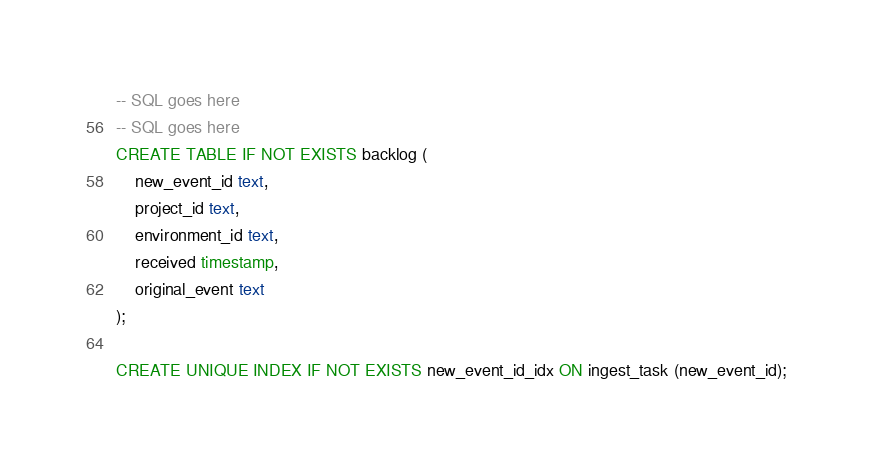Convert code to text. <code><loc_0><loc_0><loc_500><loc_500><_SQL_>-- SQL goes here
-- SQL goes here
CREATE TABLE IF NOT EXISTS backlog (
	new_event_id text,
	project_id text,
	environment_id text,
	received timestamp,
	original_event text
);

CREATE UNIQUE INDEX IF NOT EXISTS new_event_id_idx ON ingest_task (new_event_id);
</code> 